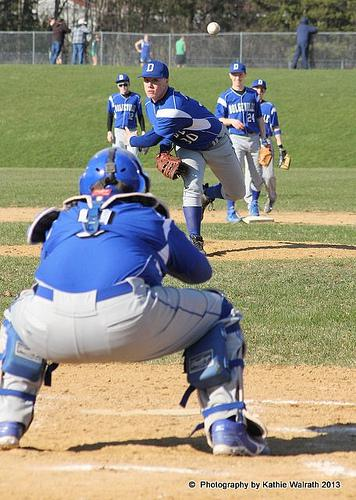Question: who are in the field?
Choices:
A. Players.
B. Sheep.
C. Farmers.
D. Runners.
Answer with the letter. Answer: A Question: how many people in the field?
Choices:
A. Four.
B. Three.
C. Five.
D. Two.
Answer with the letter. Answer: C Question: what is the color of the grasses?
Choices:
A. Brown.
B. Yellow.
C. Blue.
D. Green.
Answer with the letter. Answer: D Question: what kind of weather it is?
Choices:
A. Rainy.
B. Sunny.
C. Foggy.
D. Stormy.
Answer with the letter. Answer: B 